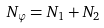<formula> <loc_0><loc_0><loc_500><loc_500>N _ { \varphi } = N _ { 1 } + N _ { 2 }</formula> 